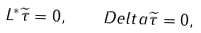Convert formula to latex. <formula><loc_0><loc_0><loc_500><loc_500>L ^ { * } \widetilde { \tau } = 0 , \ \ \ D e l t a \widetilde { \tau } = 0 ,</formula> 